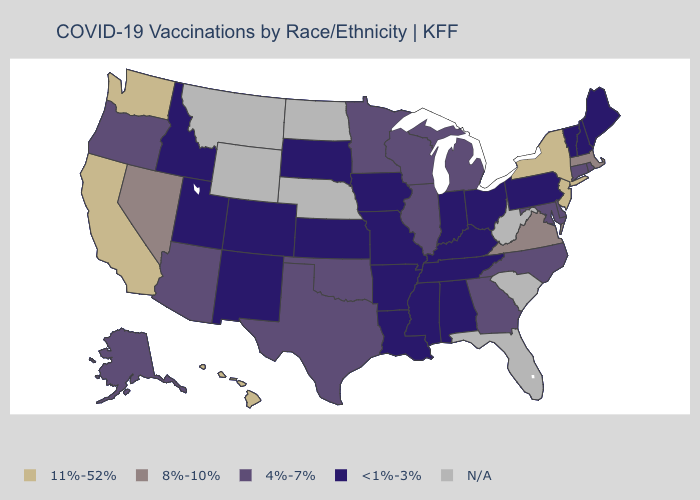Name the states that have a value in the range N/A?
Quick response, please. Florida, Montana, Nebraska, North Dakota, South Carolina, West Virginia, Wyoming. Does Louisiana have the lowest value in the South?
Give a very brief answer. Yes. What is the lowest value in the USA?
Quick response, please. <1%-3%. Which states hav the highest value in the MidWest?
Short answer required. Illinois, Michigan, Minnesota, Wisconsin. What is the highest value in the USA?
Answer briefly. 11%-52%. What is the value of Oklahoma?
Quick response, please. 4%-7%. Among the states that border Indiana , which have the highest value?
Answer briefly. Illinois, Michigan. Name the states that have a value in the range N/A?
Concise answer only. Florida, Montana, Nebraska, North Dakota, South Carolina, West Virginia, Wyoming. Which states have the highest value in the USA?
Quick response, please. California, Hawaii, New Jersey, New York, Washington. Does New Hampshire have the highest value in the Northeast?
Keep it brief. No. Name the states that have a value in the range 8%-10%?
Keep it brief. Massachusetts, Nevada, Virginia. Name the states that have a value in the range N/A?
Give a very brief answer. Florida, Montana, Nebraska, North Dakota, South Carolina, West Virginia, Wyoming. 